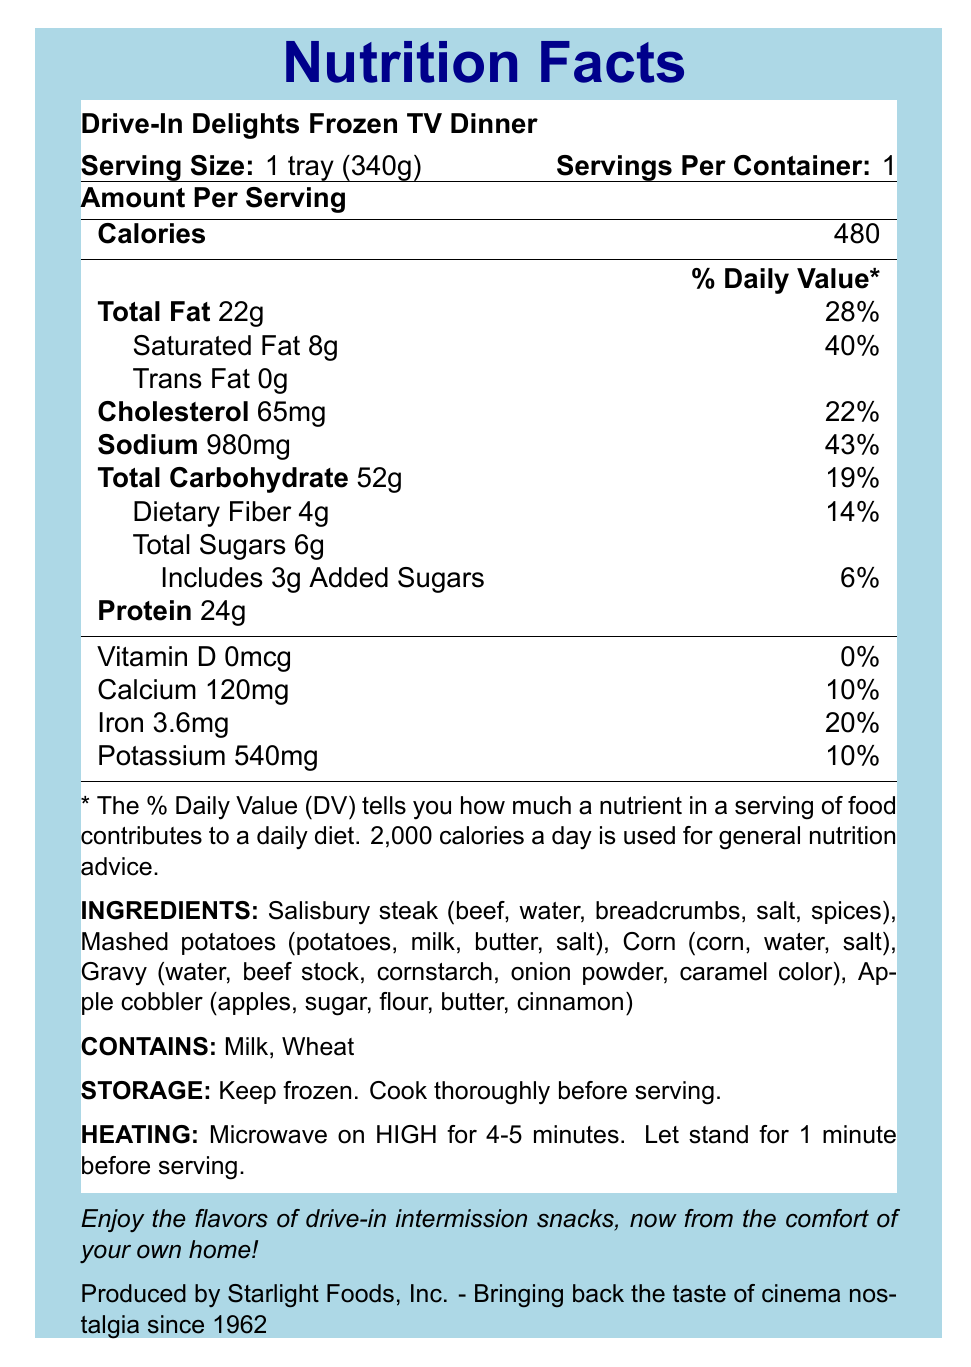What is the serving size for the Drive-In Delights Frozen TV Dinner? The serving size is shown at the top of the Nutrition Facts label as "1 tray (340g)".
Answer: 1 tray (340g) How many calories are in one serving of this TV dinner? The amount of calories per serving is listed as 480 under the "Amount Per Serving" section.
Answer: 480 What percentage of the Daily Value is the saturated fat content? The percentage daily value for saturated fat is listed as 40% next to "Saturated Fat 8g".
Answer: 40% How much sodium does one serving contain? The sodium content per serving is 980mg according to the Nutrition Facts label.
Answer: 980mg What allergens does this TV dinner contain? The allergens are listed under the "Contains" section as Milk and Wheat.
Answer: Milk, Wheat Multiple-choice: How much protein is in the Drive-In Delights Frozen TV Dinner?
a) 20g
b) 24g
c) 28g
d) 22g The nutrition label lists the protein content as 24g per serving.
Answer: b) 24g Multiple-choice: What is the daily value percentage of calcium provided by this TV dinner?
i) 5%
ii) 10%
iii) 15%
iv) 20% The daily value percentage for calcium is listed as 10% on the nutrition label.
Answer: ii) 10% Yes/No: Does this TV dinner contain any trans fat? The nutrition label shows "Trans Fat 0g,” which means there is no trans fat in this product.
Answer: No Summarize the main idea of this document. The document provides comprehensive information about the Drive-In Delights Frozen TV Dinner, including essential nutritional values, ingredient list, allergens, and preparation instructions, while highlighting its nostalgic appeal rooted in drive-in theatre snacks.
Answer: The document is a Nutrition Facts label for the Drive-In Delights Frozen TV Dinner, detailing its nutritional content per serving, ingredients, allergens, storage and heating instructions, and a nostalgic note about its connection to drive-in theatre foods. Where is Starlight Foods, Inc. located? The document lists Starlight Foods, Inc. as the manufacturer but does not provide location information.
Answer: Cannot be determined 